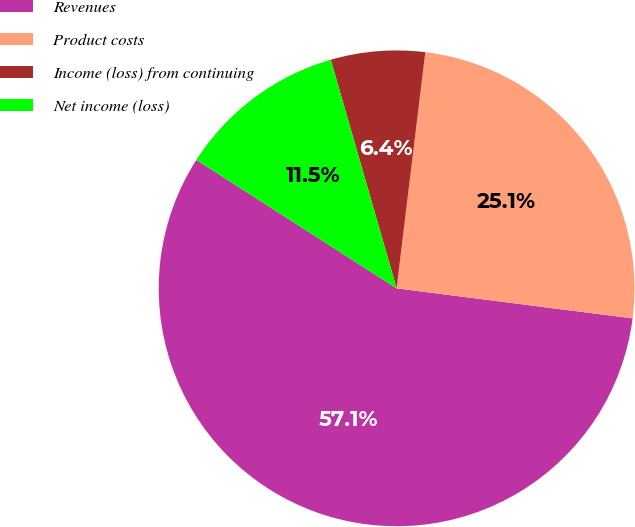Convert chart to OTSL. <chart><loc_0><loc_0><loc_500><loc_500><pie_chart><fcel>Revenues<fcel>Product costs<fcel>Income (loss) from continuing<fcel>Net income (loss)<nl><fcel>57.06%<fcel>25.09%<fcel>6.39%<fcel>11.46%<nl></chart> 